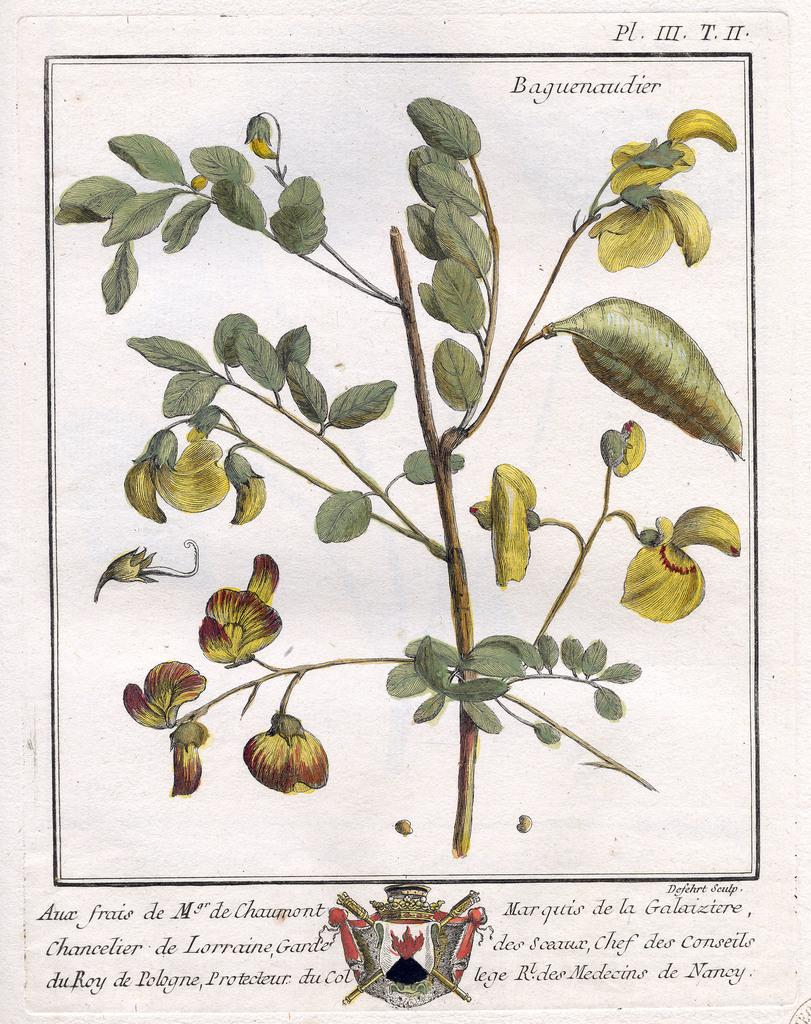What is the main subject of the image? The image contains an art piece. Are there any living elements in the image? Yes, there is a plant in the image. Where can text be found in the image? Text is present at the bottom and top of the image. What other visual element is present at the bottom of the image? There is a symbol visible at the bottom of the image. What type of cream is being advertised in the image? There is no cream being advertised in the image; it contains an art piece, a plant, and text with a symbol. 